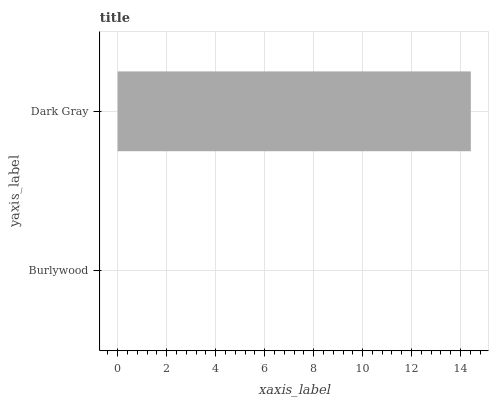Is Burlywood the minimum?
Answer yes or no. Yes. Is Dark Gray the maximum?
Answer yes or no. Yes. Is Dark Gray the minimum?
Answer yes or no. No. Is Dark Gray greater than Burlywood?
Answer yes or no. Yes. Is Burlywood less than Dark Gray?
Answer yes or no. Yes. Is Burlywood greater than Dark Gray?
Answer yes or no. No. Is Dark Gray less than Burlywood?
Answer yes or no. No. Is Dark Gray the high median?
Answer yes or no. Yes. Is Burlywood the low median?
Answer yes or no. Yes. Is Burlywood the high median?
Answer yes or no. No. Is Dark Gray the low median?
Answer yes or no. No. 